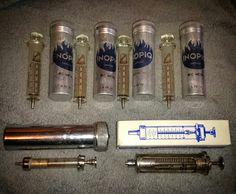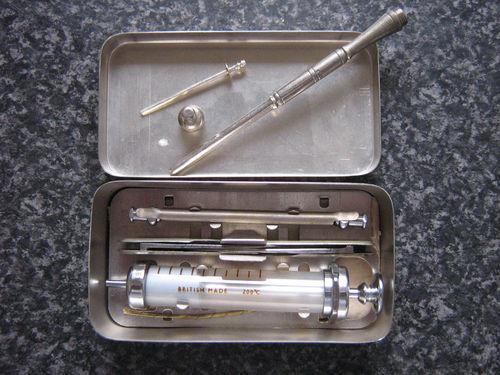The first image is the image on the left, the second image is the image on the right. For the images displayed, is the sentence "An image shows one open rectangular metal case with syringe items inside of it." factually correct? Answer yes or no. Yes. 